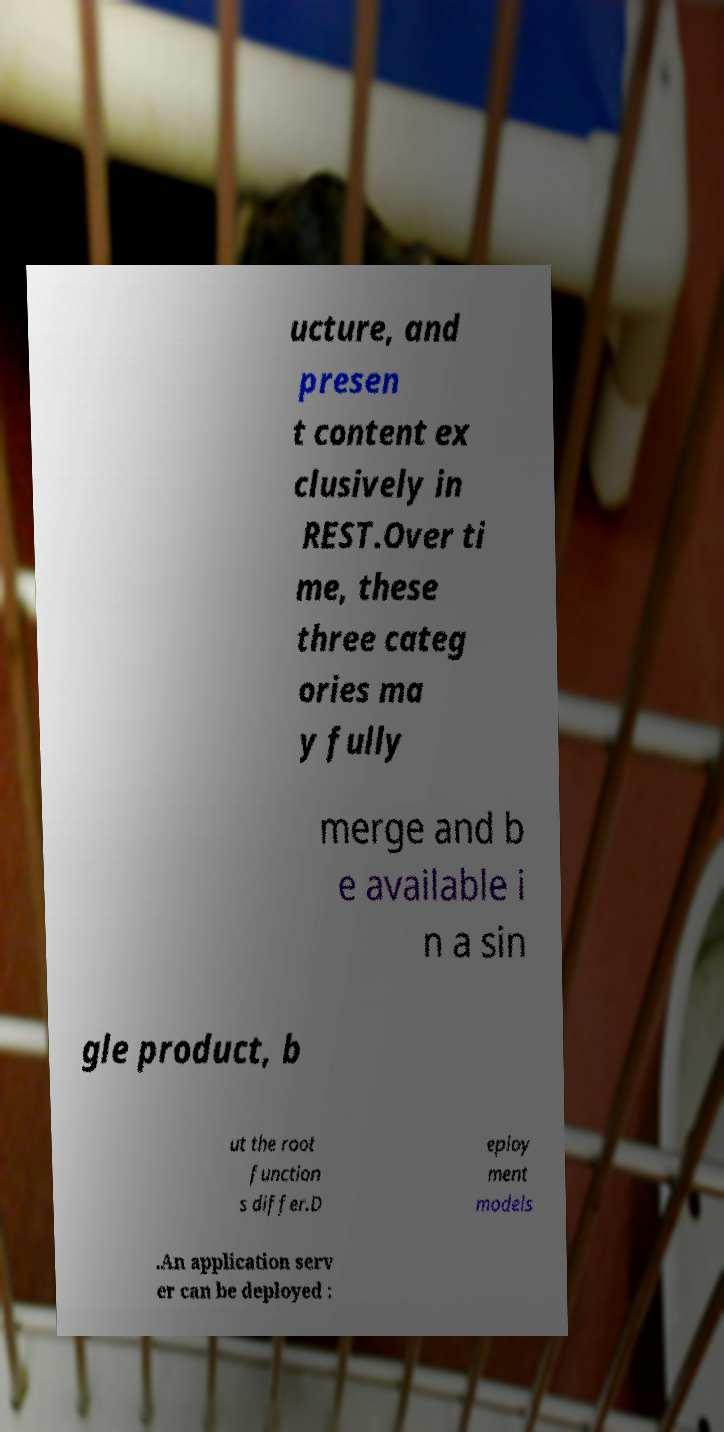For documentation purposes, I need the text within this image transcribed. Could you provide that? ucture, and presen t content ex clusively in REST.Over ti me, these three categ ories ma y fully merge and b e available i n a sin gle product, b ut the root function s differ.D eploy ment models .An application serv er can be deployed : 